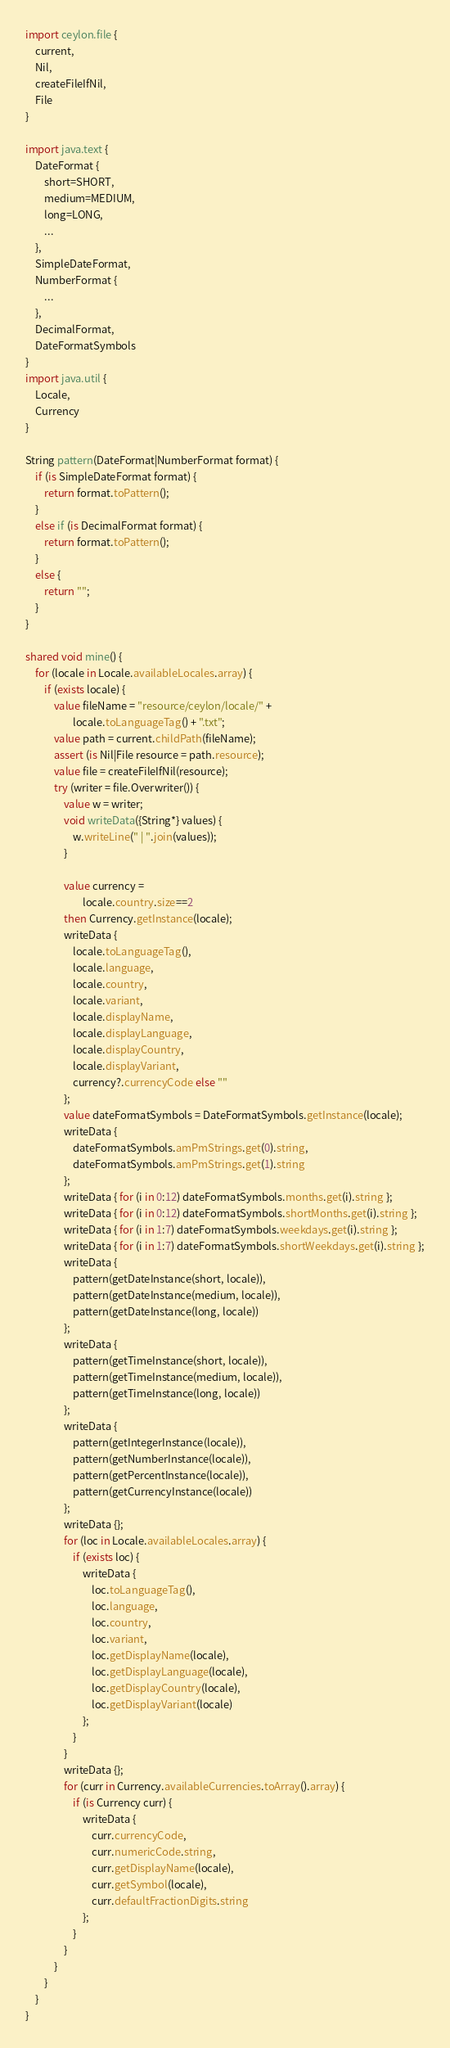<code> <loc_0><loc_0><loc_500><loc_500><_Ceylon_>import ceylon.file {
    current,
    Nil,
    createFileIfNil,
    File
}

import java.text {
    DateFormat {
        short=SHORT,
        medium=MEDIUM,
        long=LONG,
        ...
    },
    SimpleDateFormat,
    NumberFormat {
        ...
    },
    DecimalFormat,
    DateFormatSymbols
}
import java.util {
    Locale,
    Currency
}

String pattern(DateFormat|NumberFormat format) {
    if (is SimpleDateFormat format) {
        return format.toPattern();
    }
    else if (is DecimalFormat format) {
        return format.toPattern();
    }
    else {
        return "";
    }
}

shared void mine() {
    for (locale in Locale.availableLocales.array) {
        if (exists locale) {
            value fileName = "resource/ceylon/locale/" + 
                    locale.toLanguageTag() + ".txt";
            value path = current.childPath(fileName);
            assert (is Nil|File resource = path.resource);
            value file = createFileIfNil(resource);
            try (writer = file.Overwriter()) {
                value w = writer;
                void writeData({String*} values) {
                    w.writeLine(" | ".join(values));
                }
            
                value currency = 
                        locale.country.size==2 
                then Currency.getInstance(locale);
                writeData {
                    locale.toLanguageTag(),
                    locale.language,
                    locale.country,
                    locale.variant,
                    locale.displayName,
                    locale.displayLanguage,
                    locale.displayCountry,
                    locale.displayVariant,
                    currency?.currencyCode else ""
                };
                value dateFormatSymbols = DateFormatSymbols.getInstance(locale);
                writeData { 
                    dateFormatSymbols.amPmStrings.get(0).string,
                    dateFormatSymbols.amPmStrings.get(1).string
                };
                writeData { for (i in 0:12) dateFormatSymbols.months.get(i).string };
                writeData { for (i in 0:12) dateFormatSymbols.shortMonths.get(i).string };
                writeData { for (i in 1:7) dateFormatSymbols.weekdays.get(i).string };
                writeData { for (i in 1:7) dateFormatSymbols.shortWeekdays.get(i).string };
                writeData {
                    pattern(getDateInstance(short, locale)),
                    pattern(getDateInstance(medium, locale)),
                    pattern(getDateInstance(long, locale))
                };
                writeData {
                    pattern(getTimeInstance(short, locale)),
                    pattern(getTimeInstance(medium, locale)),
                    pattern(getTimeInstance(long, locale))
                };
                writeData {
                    pattern(getIntegerInstance(locale)),
                    pattern(getNumberInstance(locale)),
                    pattern(getPercentInstance(locale)),
                    pattern(getCurrencyInstance(locale))
                };
                writeData {};
                for (loc in Locale.availableLocales.array) {
                    if (exists loc) {
                        writeData { 
                            loc.toLanguageTag(),
                            loc.language,
                            loc.country,
                            loc.variant,
                            loc.getDisplayName(locale),
                            loc.getDisplayLanguage(locale),
                            loc.getDisplayCountry(locale),
                            loc.getDisplayVariant(locale)
                        };
                    }
                }
                writeData {};
                for (curr in Currency.availableCurrencies.toArray().array) {
                    if (is Currency curr) {
                        writeData {
                            curr.currencyCode,
                            curr.numericCode.string,
                            curr.getDisplayName(locale),
                            curr.getSymbol(locale),
                            curr.defaultFractionDigits.string
                        };
                    }
                }
            }
        }
    }
}</code> 